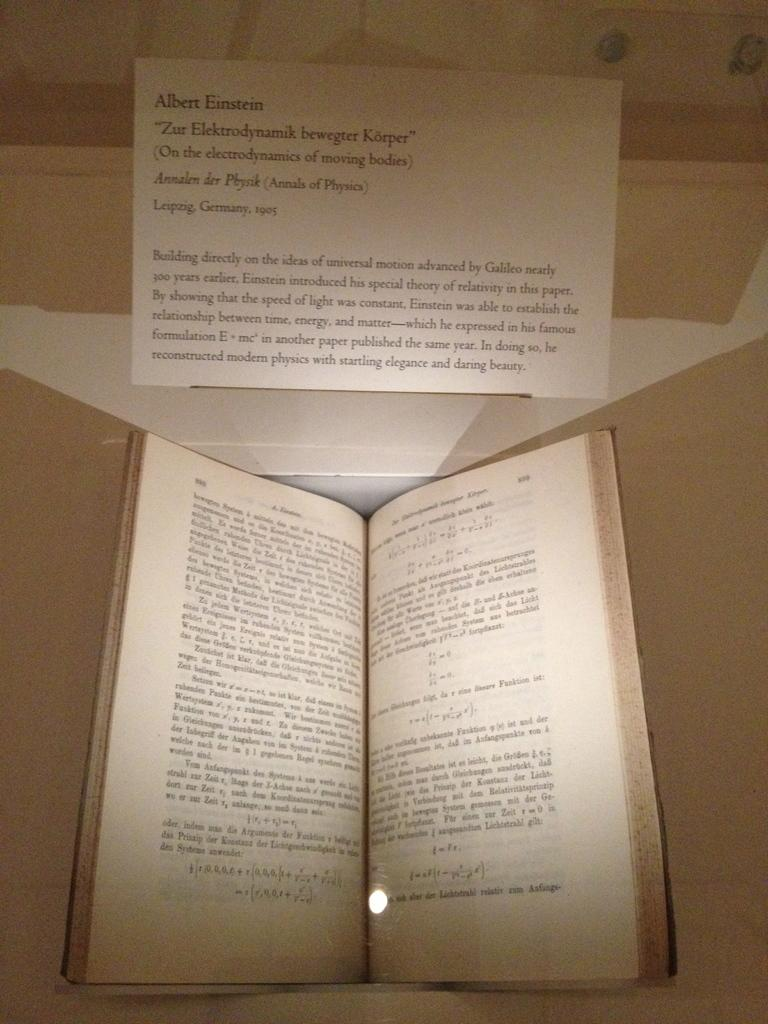<image>
Offer a succinct explanation of the picture presented. A physics book is open to pages 898 and 899. 